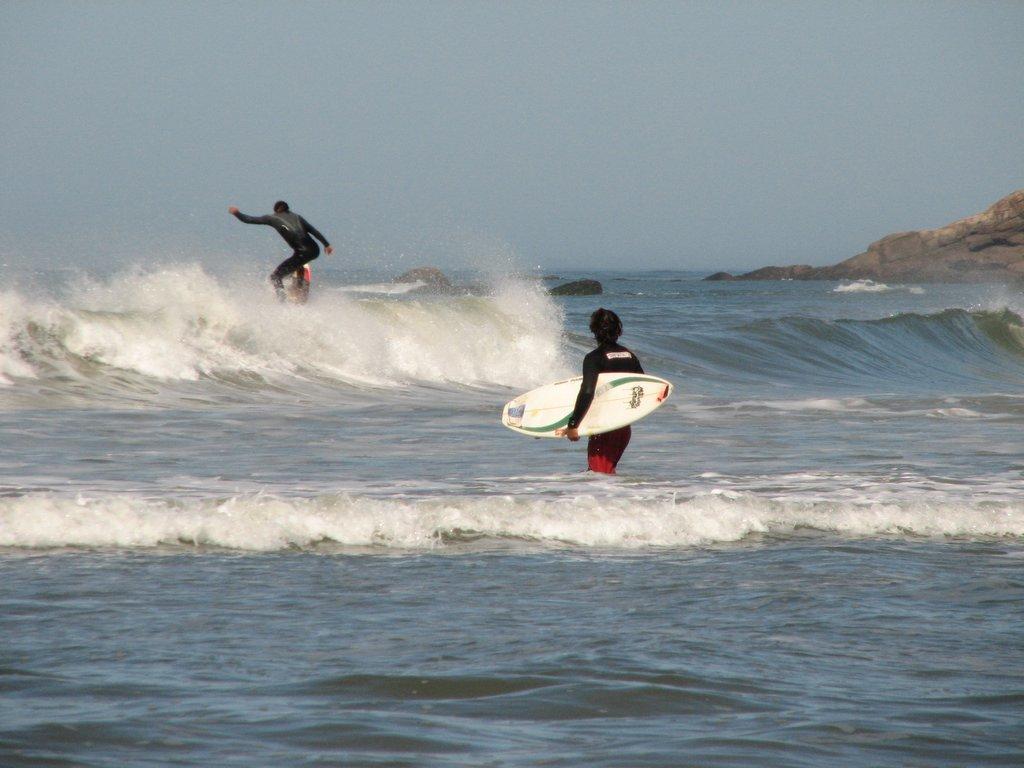How would you summarize this image in a sentence or two? In this picture I can see there is a person surfing in the water, the person is wearing a swim suit and there is another person standing here, holding the surfing board. There is a mountain into right and the sky is clear. 